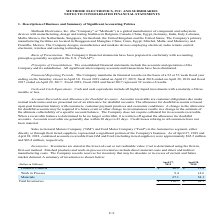According to Methode Electronics's financial document, Which method is used to calculate cost? Based on the financial document, the answer is first-in, first-out method. Also, Which costs are included in Finished products and work-in-progress? direct material costs and direct and indirect manufacturing costs. The document states: "products and work-in-process inventories include direct material costs and direct and indirect manufacturing costs. The Company records reserves for i..." Also, What was the value of finished products in 2019 and 2018 respectively? The document shows two values: $40.2 and $15.4 (in millions). From the document: "Finished Products $ 40.2 $ 15.4 Finished Products $ 40.2 $ 15.4..." Also, can you calculate: What was the change in the value of finished products from 2018 to 2019? Based on the calculation: 40.2 - 15.4, the result is 24.8 (in millions). This is based on the information: "Finished Products $ 40.2 $ 15.4 Finished Products $ 40.2 $ 15.4..." The key data points involved are: 15.4, 40.2. Also, can you calculate: What is the average work in progress value for 2018 and 2019? To answer this question, I need to perform calculations using the financial data. The calculation is: (9.4 + 14.6) / 2, which equals 12 (in millions). This is based on the information: "Work in Process 9.4 14.6 Work in Process 9.4 14.6..." The key data points involved are: 14.6, 9.4. Additionally, In which year was materials value less than 60 million? According to the financial document, 2018. The relevant text states: "l 30. Fiscal 2019 ended on April 27, 2019, fiscal 2018 ended on April 28, 2018 and fiscal 2017 ended on April 29, 2017. Fiscal 2019, fiscal 2018 and fisca..." 